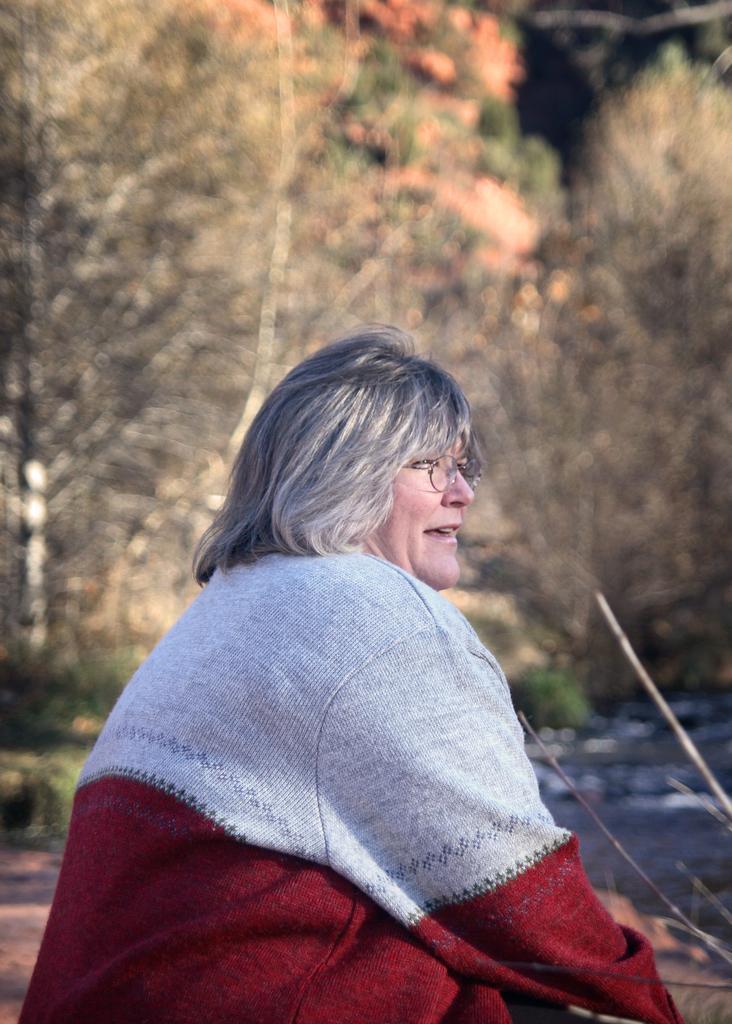Can you describe this image briefly? In this picture I can see a person with spectacles, there is water, and in the background there are trees. 